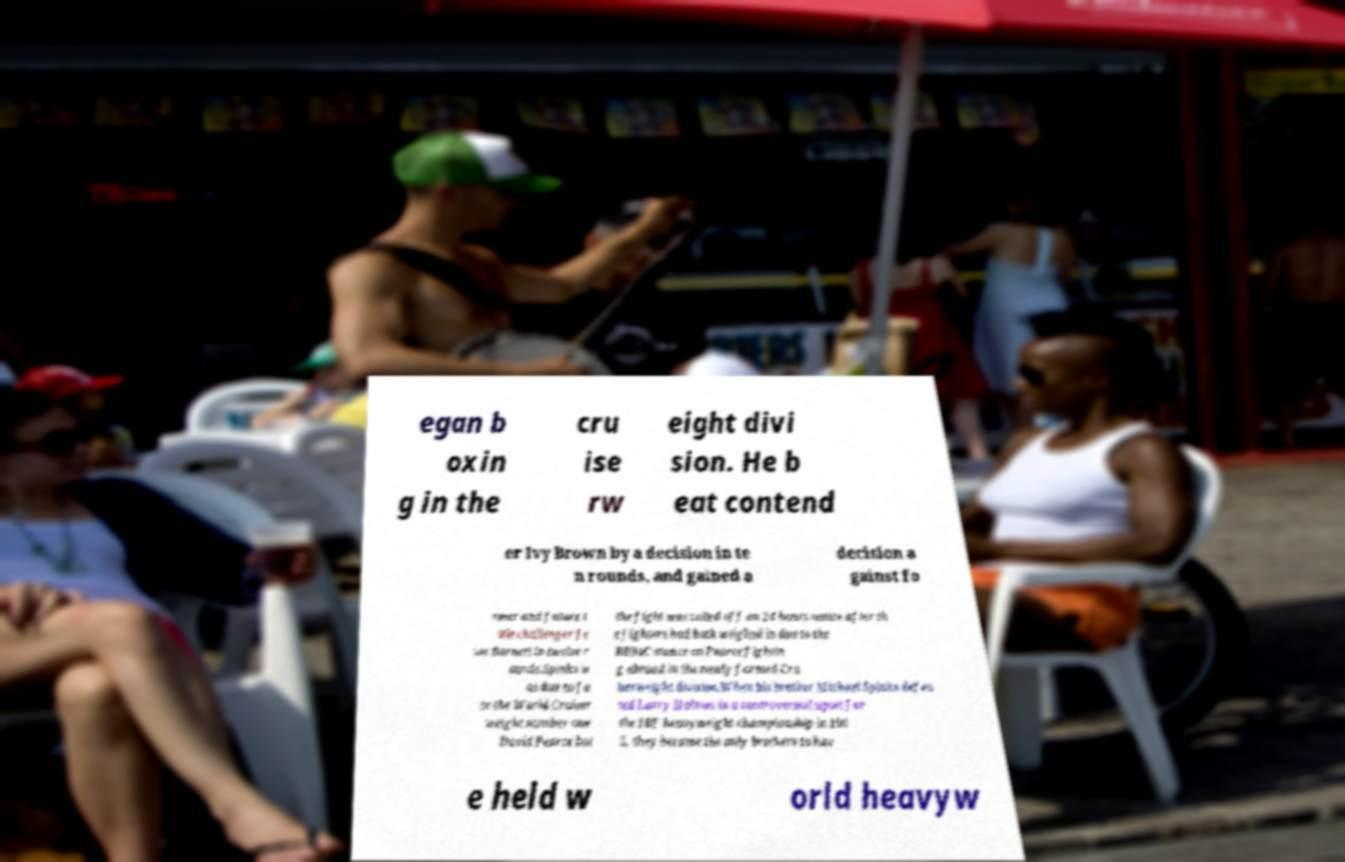I need the written content from this picture converted into text. Can you do that? egan b oxin g in the cru ise rw eight divi sion. He b eat contend er Ivy Brown by a decision in te n rounds, and gained a decision a gainst fo rmer and future t itle challenger Je sse Burnett in twelve r ounds.Spinks w as due to fa ce the World Cruiser weight number one David Pearce but the fight was called off on 24 hours notice after th e fighters had both weighed in due to the BBBoC stance on Pearce fightin g abroad in the newly formed Cru iserweight division.When his brother Michael Spinks defea ted Larry Holmes in a controversial upset for the IBF heavyweight championship in 198 5, they became the only brothers to hav e held w orld heavyw 